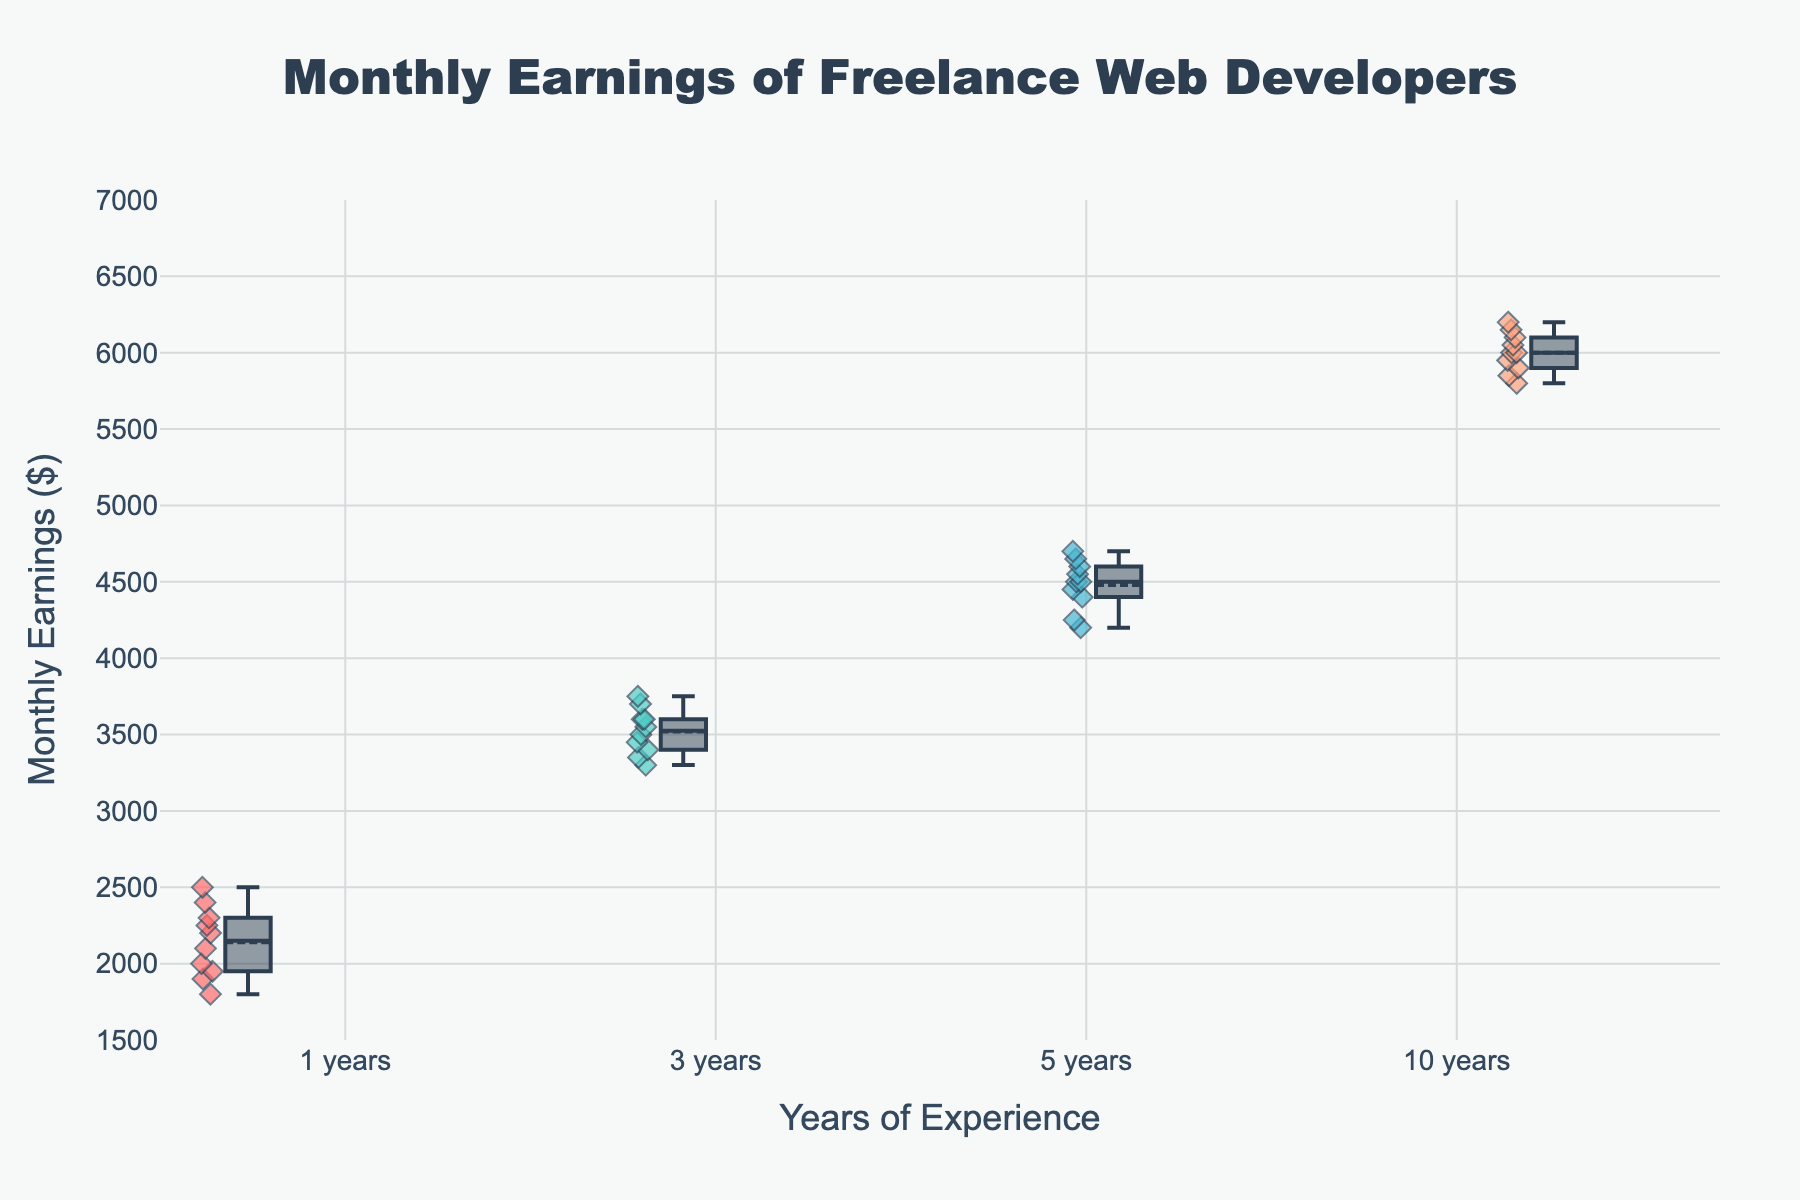What is the title of the box plot? The title of the box plot is displayed prominently at the top of the figure.
Answer: Monthly Earnings of Freelance Web Developers Which group has the highest median monthly earnings? By looking at the lines inside the boxes, which represent the median values for each group, we can see that the group with 10 years of experience has the highest median.
Answer: 10 years How many years of experience groups are displayed in the box plot? There are labels along the x-axis of the box plot representing different groups of years of experience. Counting these labels will give the number of groups.
Answer: 4 What is the range of monthly earnings for developers with 5 years of experience? The range of a box plot is from the bottom whisker to the top whisker. For the 5 years experience group, this range is from around 4200 to 4700.
Answer: 4200 to 4700 What does the diamond marker indicate in the box plot? Diamond markers typically indicate individual data points in the box plot, showing distribution and spread.
Answer: Individual data points Which group shows the greatest spread in monthly earnings? The spread of a group in a box plot is indicated by the length of the box and whiskers. The 10 years experience group has the widest spread.
Answer: 10 years How does the median monthly earning of the 3 years experience group compare to that of the 1-year experience group? Locate the median lines (inside the boxes) for both groups and compare their positions; the median for 3 years is significantly higher than that for 1 year.
Answer: Higher What is the interquartile range (IQR) of the group with 1 year of experience? The IQR is the range between the first and third quartiles (the bottom and top of the box). For 1 year, it's from around 1900 to 2300.
Answer: 400 Are there any outliers in the 10 years experience group? Outliers in a box plot are marked as individual points beyond the whiskers' range. For the 10 years experience group, no such points are present.
Answer: No What is the average of the median monthly earnings for all four groups? First find the medians of each group (1 year: 2200, 3 years: 3550, 5 years: 4500, 10 years: 6000). Then average these values: (2200 + 3550 + 4500 + 6000) / 4.
Answer: 4062.5 